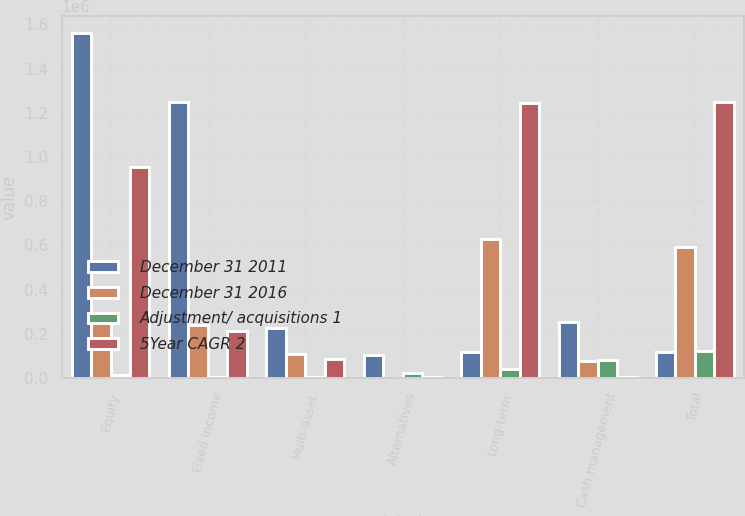<chart> <loc_0><loc_0><loc_500><loc_500><stacked_bar_chart><ecel><fcel>Equity<fcel>Fixed income<fcel>Multi-asset<fcel>Alternatives<fcel>Long-term<fcel>Cash management<fcel>Total<nl><fcel>December 31 2011<fcel>1.56011e+06<fcel>1.24772e+06<fcel>225170<fcel>104948<fcel>115970<fcel>254665<fcel>115970<nl><fcel>December 31 2016<fcel>279876<fcel>238004<fcel>108411<fcel>2187<fcel>628478<fcel>77538<fcel>593632<nl><fcel>Adjustment/ acquisitions 1<fcel>11461<fcel>3494<fcel>6442<fcel>21497<fcel>42894<fcel>80635<fcel>123529<nl><fcel>5Year CAGR 2<fcel>952669<fcel>212383<fcel>85031<fcel>3398<fcel>1.24668e+06<fcel>3789<fcel>1.25063e+06<nl></chart> 